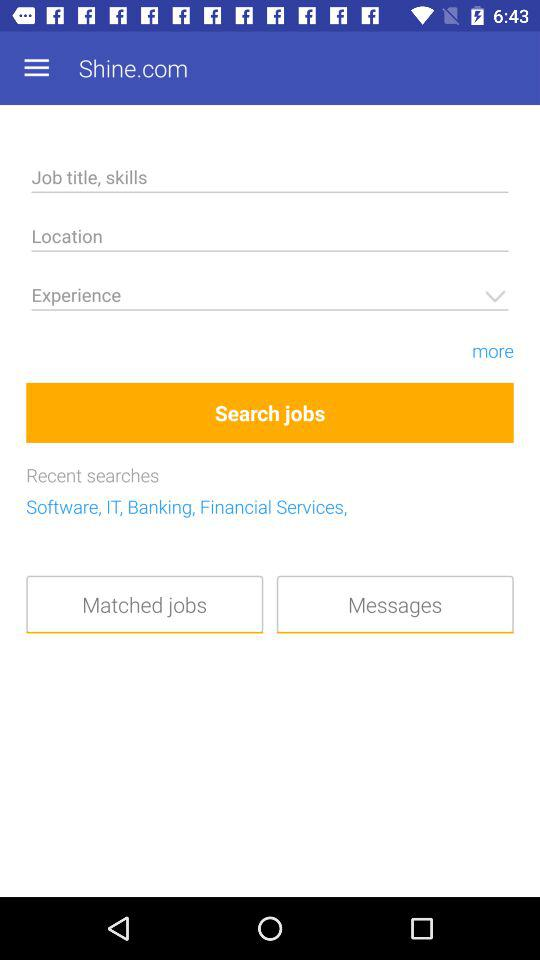What is the app name? The app name is "Shine.com". 